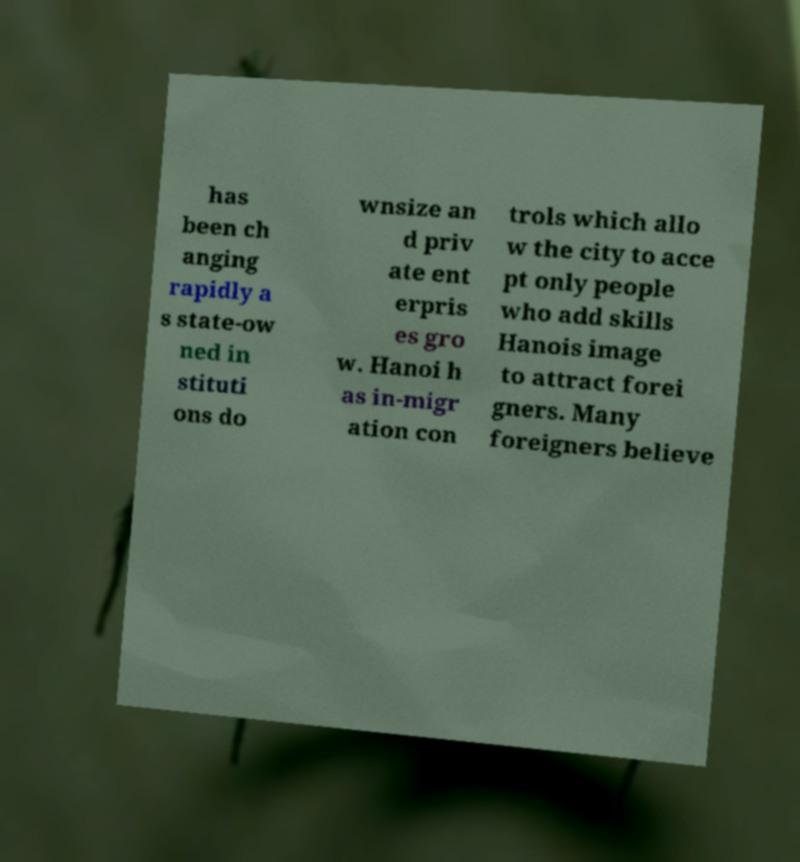There's text embedded in this image that I need extracted. Can you transcribe it verbatim? has been ch anging rapidly a s state-ow ned in stituti ons do wnsize an d priv ate ent erpris es gro w. Hanoi h as in-migr ation con trols which allo w the city to acce pt only people who add skills Hanois image to attract forei gners. Many foreigners believe 